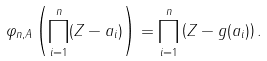Convert formula to latex. <formula><loc_0><loc_0><loc_500><loc_500>\varphi _ { n , A } \left ( \prod _ { i = 1 } ^ { n } ( Z - a _ { i } ) \right ) = \prod _ { i = 1 } ^ { n } \left ( Z - g ( a _ { i } ) \right ) .</formula> 